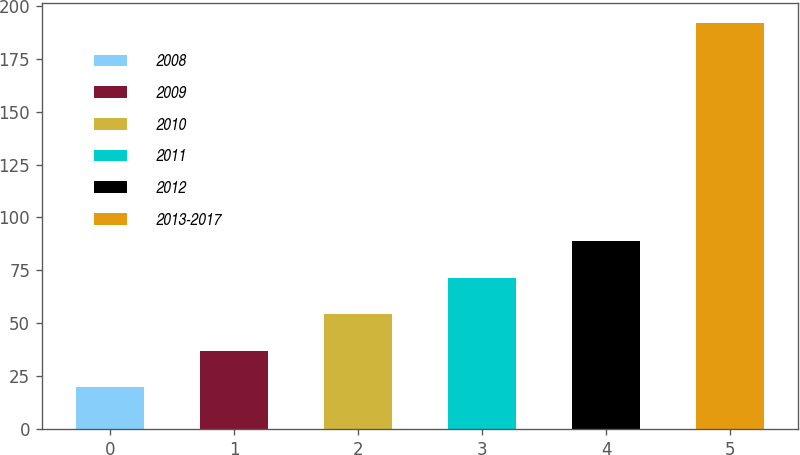Convert chart to OTSL. <chart><loc_0><loc_0><loc_500><loc_500><bar_chart><fcel>2008<fcel>2009<fcel>2010<fcel>2011<fcel>2012<fcel>2013-2017<nl><fcel>19.9<fcel>37.1<fcel>54.3<fcel>71.5<fcel>88.7<fcel>191.9<nl></chart> 